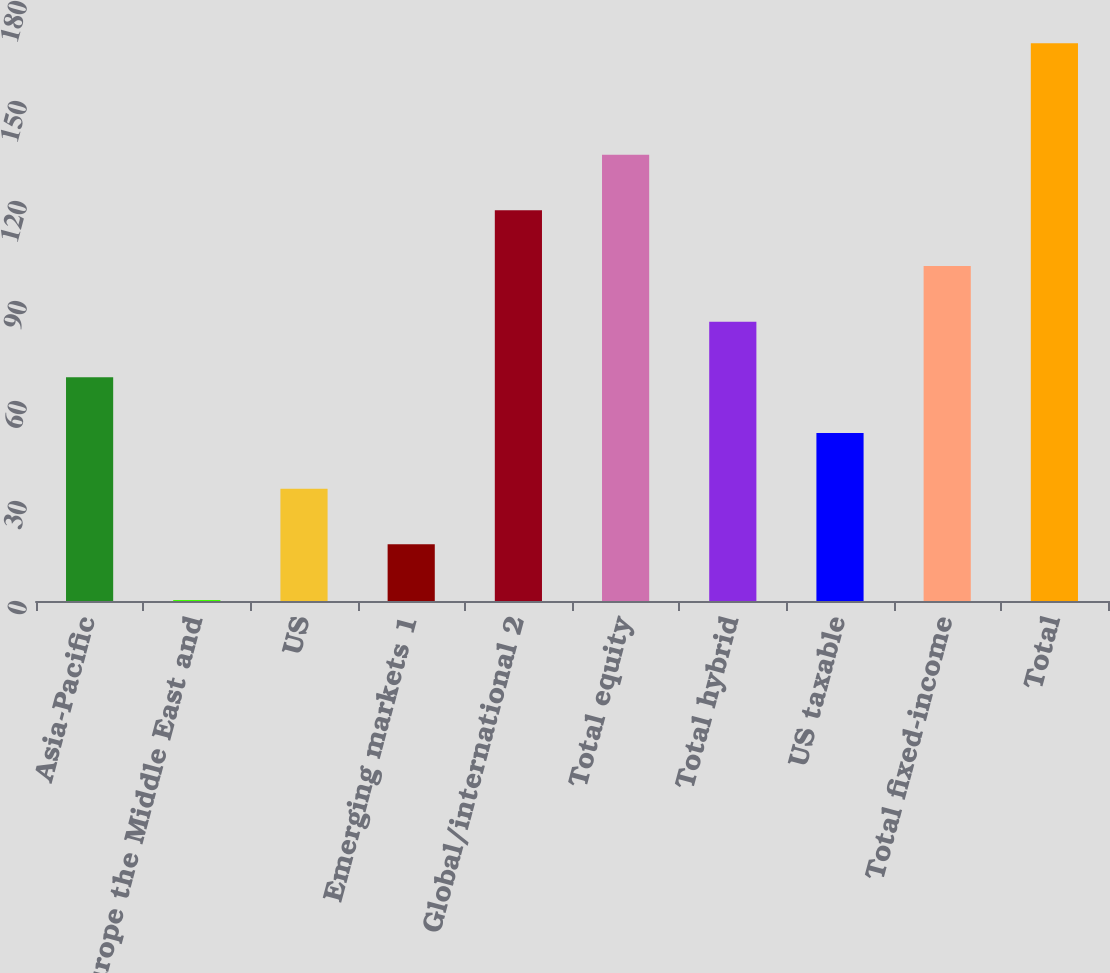<chart> <loc_0><loc_0><loc_500><loc_500><bar_chart><fcel>Asia-Pacific<fcel>Europe the Middle East and<fcel>US<fcel>Emerging markets 1<fcel>Global/international 2<fcel>Total equity<fcel>Total hybrid<fcel>US taxable<fcel>Total fixed-income<fcel>Total<nl><fcel>67.1<fcel>0.3<fcel>33.7<fcel>17<fcel>117.2<fcel>133.9<fcel>83.8<fcel>50.4<fcel>100.5<fcel>167.3<nl></chart> 